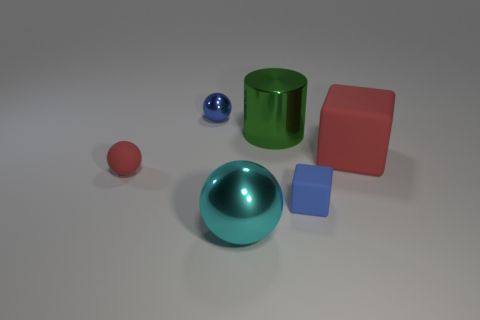Add 1 gray rubber cylinders. How many objects exist? 7 Subtract all cubes. How many objects are left? 4 Add 1 tiny red things. How many tiny red things are left? 2 Add 2 red shiny things. How many red shiny things exist? 2 Subtract 1 red blocks. How many objects are left? 5 Subtract all large brown blocks. Subtract all small red objects. How many objects are left? 5 